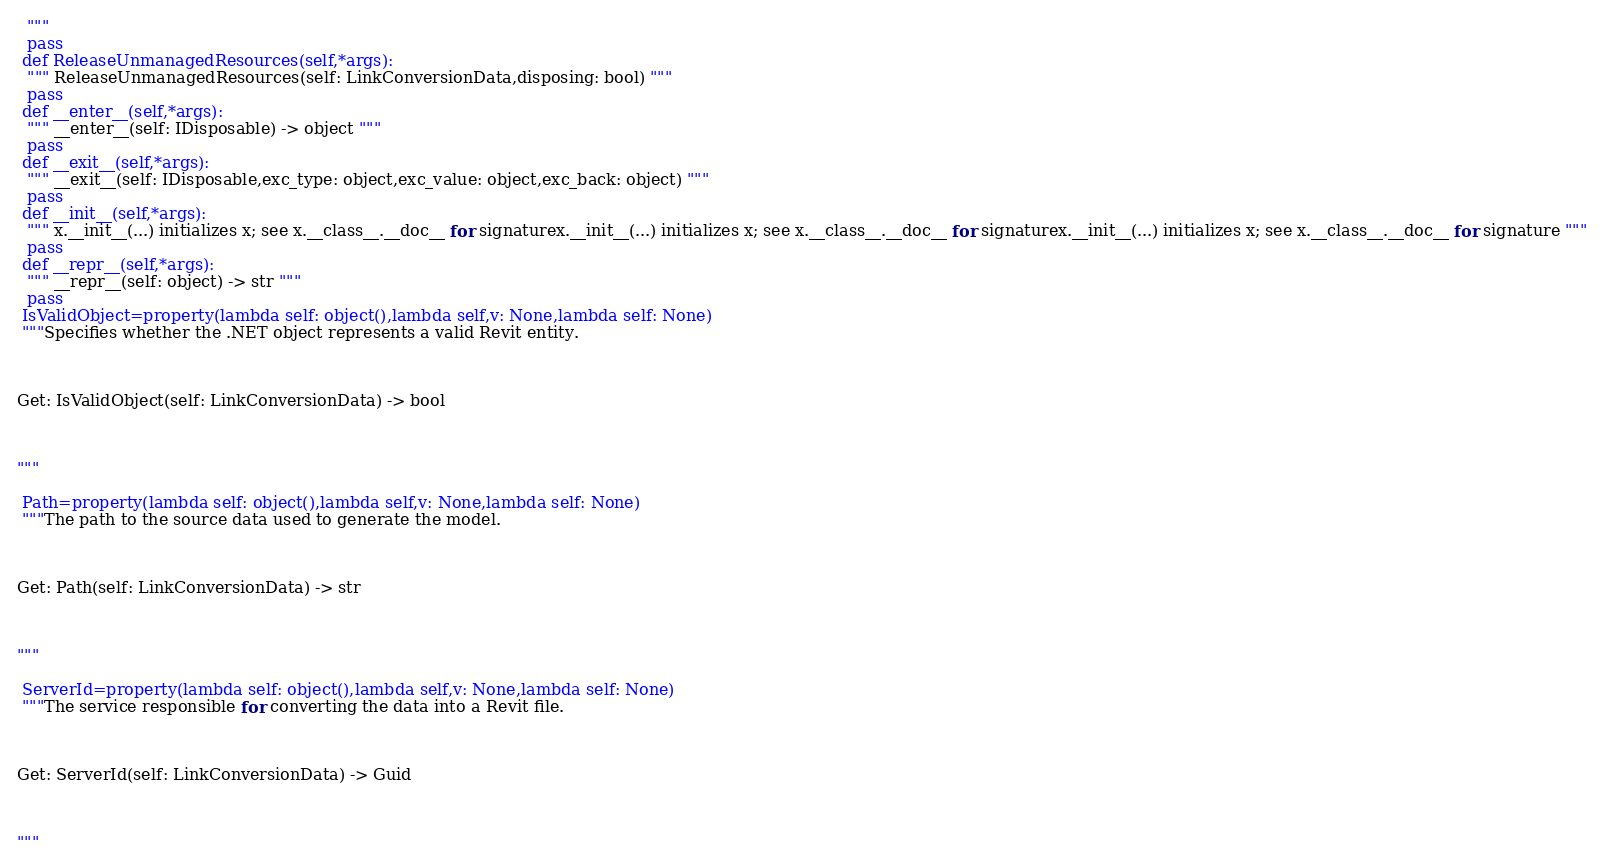Convert code to text. <code><loc_0><loc_0><loc_500><loc_500><_Python_>  """
  pass
 def ReleaseUnmanagedResources(self,*args):
  """ ReleaseUnmanagedResources(self: LinkConversionData,disposing: bool) """
  pass
 def __enter__(self,*args):
  """ __enter__(self: IDisposable) -> object """
  pass
 def __exit__(self,*args):
  """ __exit__(self: IDisposable,exc_type: object,exc_value: object,exc_back: object) """
  pass
 def __init__(self,*args):
  """ x.__init__(...) initializes x; see x.__class__.__doc__ for signaturex.__init__(...) initializes x; see x.__class__.__doc__ for signaturex.__init__(...) initializes x; see x.__class__.__doc__ for signature """
  pass
 def __repr__(self,*args):
  """ __repr__(self: object) -> str """
  pass
 IsValidObject=property(lambda self: object(),lambda self,v: None,lambda self: None)
 """Specifies whether the .NET object represents a valid Revit entity.



Get: IsValidObject(self: LinkConversionData) -> bool



"""

 Path=property(lambda self: object(),lambda self,v: None,lambda self: None)
 """The path to the source data used to generate the model.



Get: Path(self: LinkConversionData) -> str



"""

 ServerId=property(lambda self: object(),lambda self,v: None,lambda self: None)
 """The service responsible for converting the data into a Revit file.



Get: ServerId(self: LinkConversionData) -> Guid



"""


</code> 